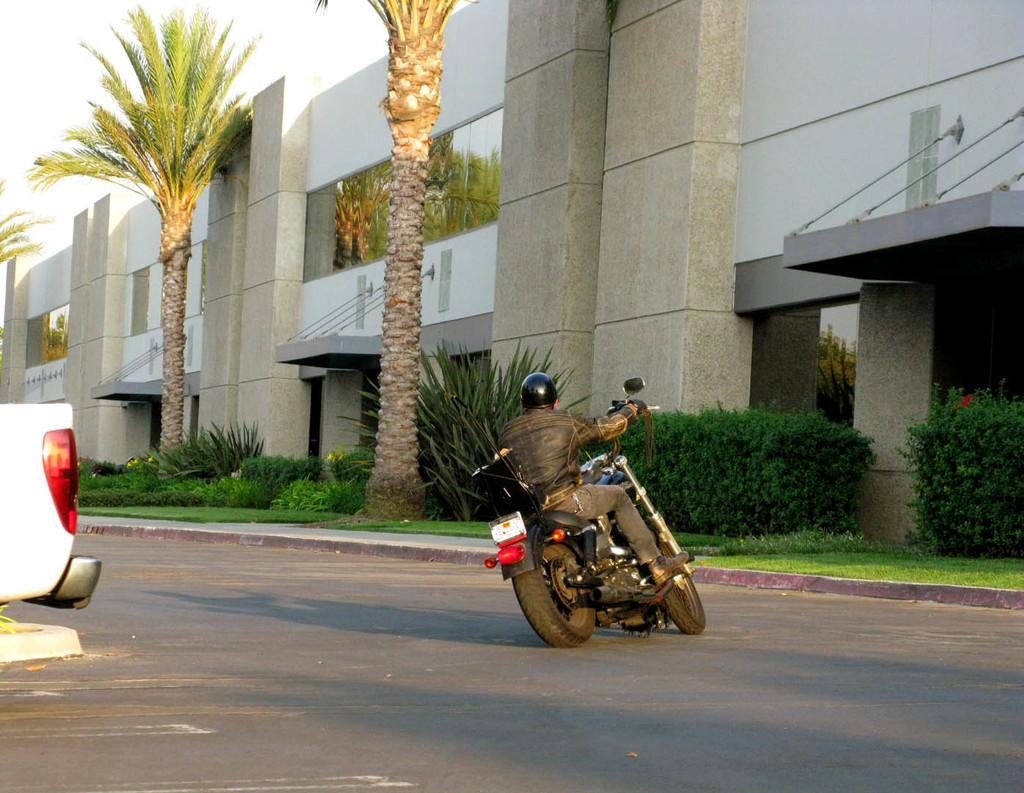Please provide a concise description of this image. There is man riding a motorbike on the road. There are some plants and trees here. In the background there is a building and a sky. 